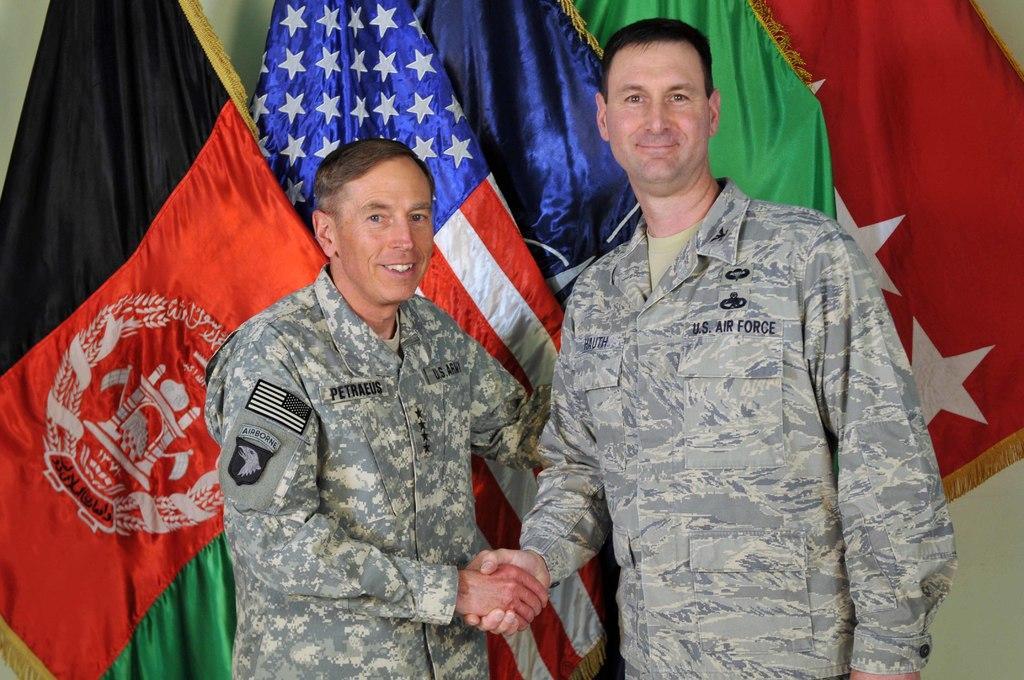Describe this image in one or two sentences. In the center of the image we can see two persons are standing and they are in different costumes. And we can see they are smiling and they are holding hands. In the background there is a wall and flags. 